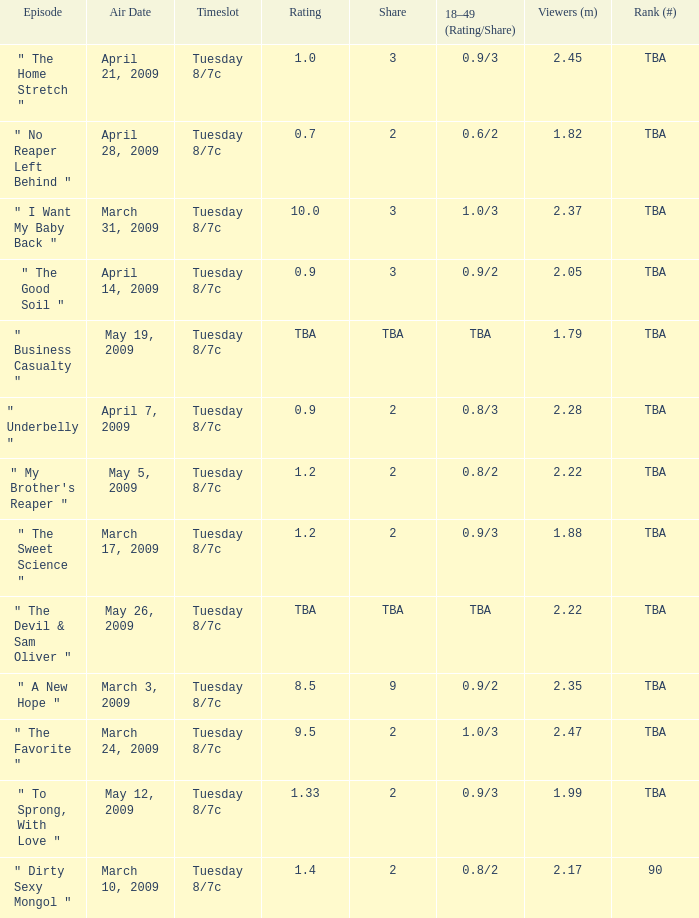What is the rating of the show ranked tba, aired on April 21, 2009? 1.0. 